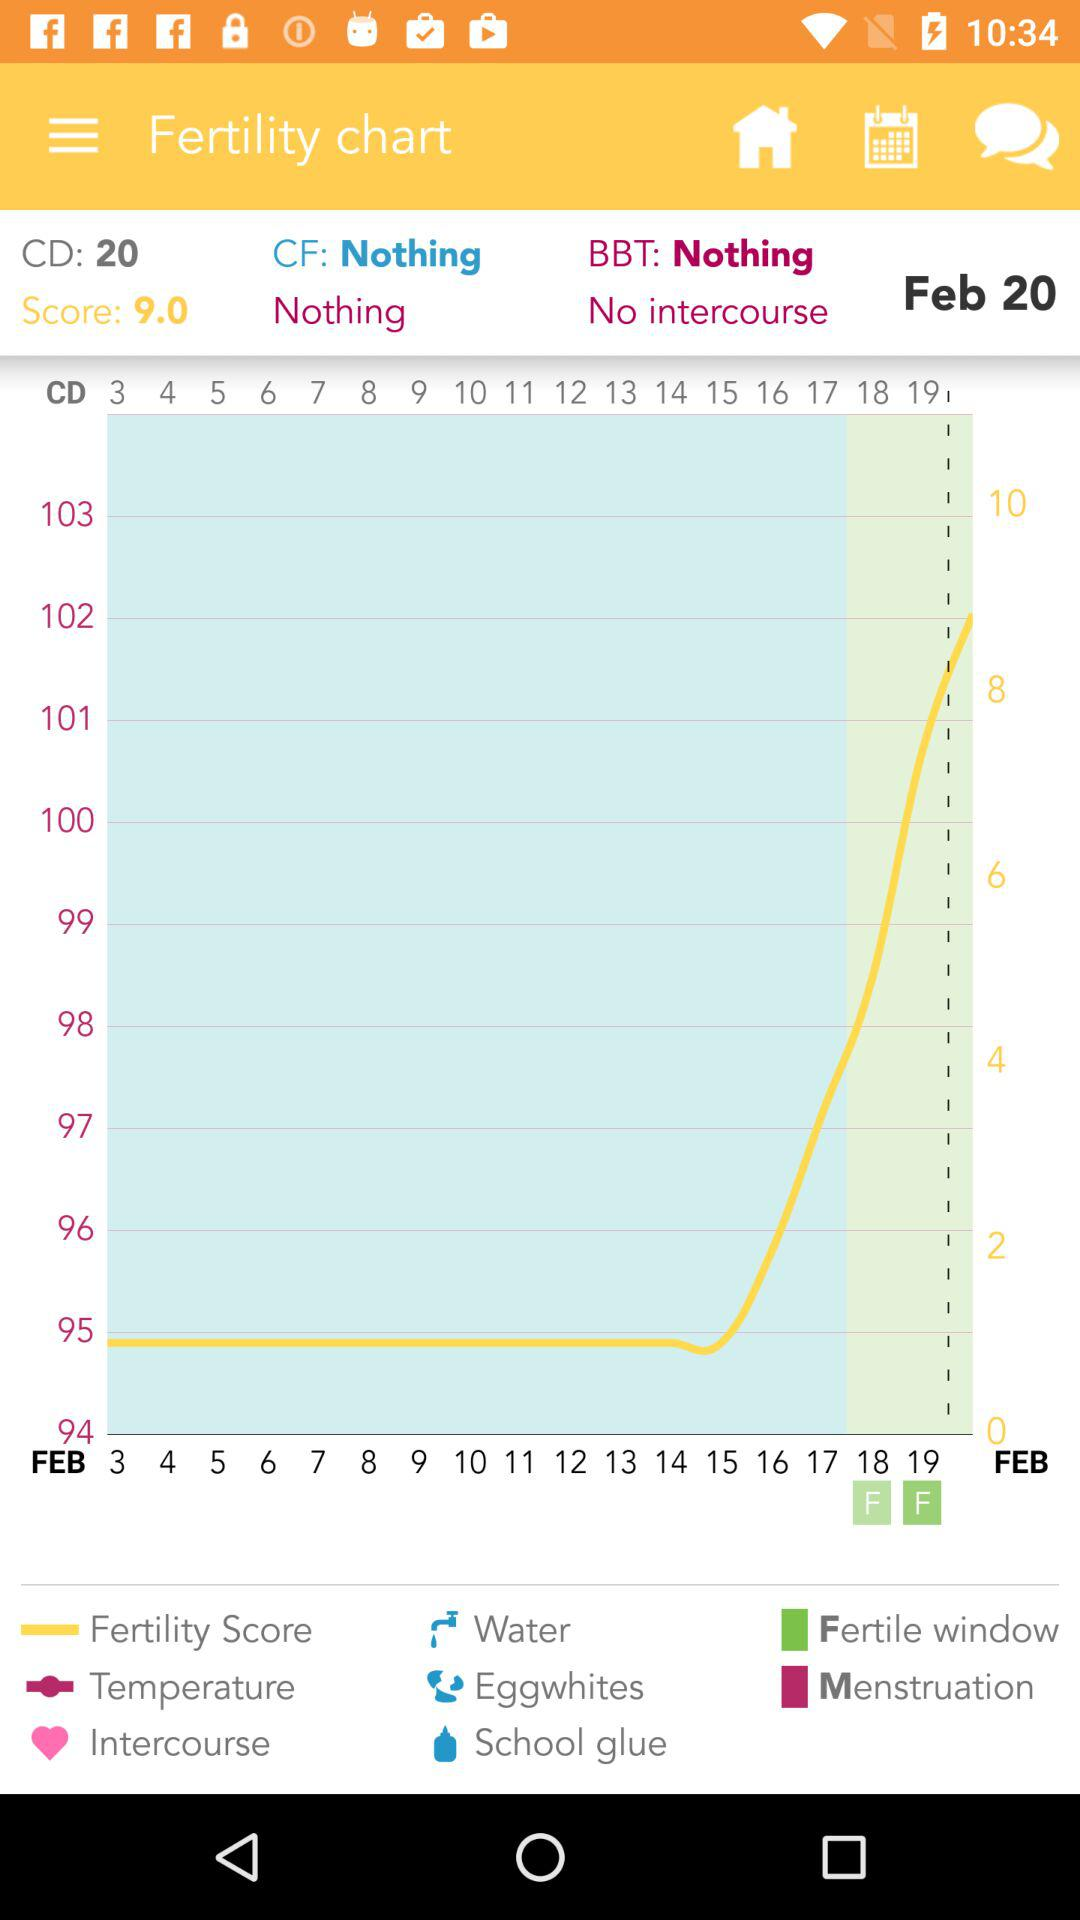What is the date? The date is February 20. 